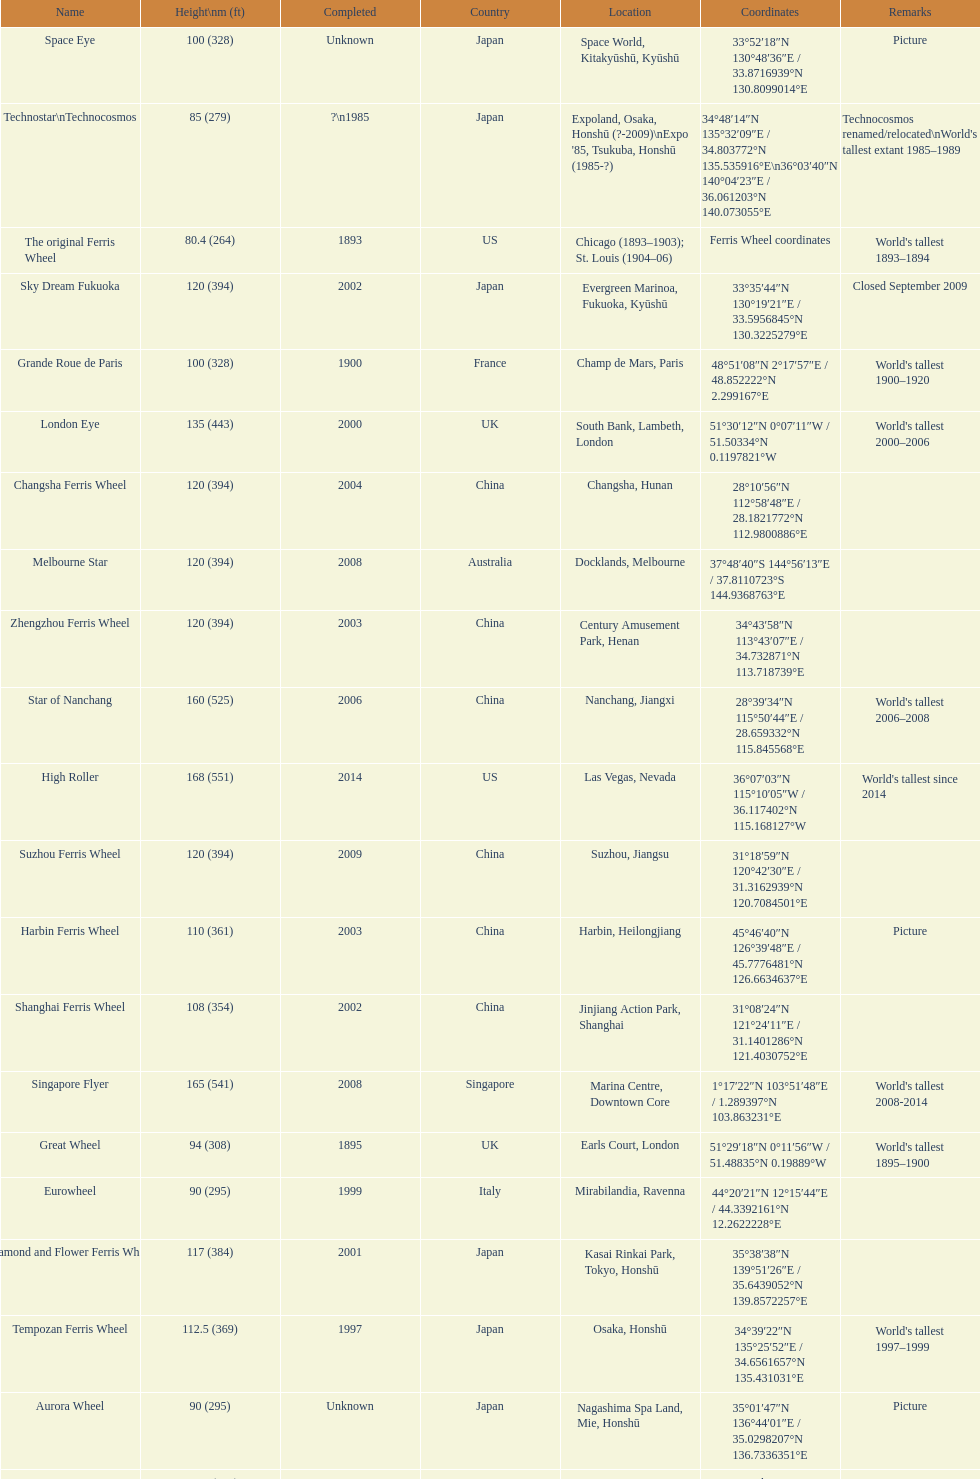Which ferris wheel was completed in 2008 and has the height of 165? Singapore Flyer. 